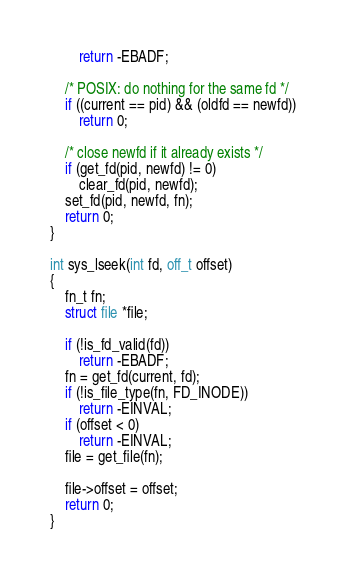Convert code to text. <code><loc_0><loc_0><loc_500><loc_500><_C_>        return -EBADF;

    /* POSIX: do nothing for the same fd */
    if ((current == pid) && (oldfd == newfd))
        return 0;

    /* close newfd if it already exists */
    if (get_fd(pid, newfd) != 0)
        clear_fd(pid, newfd);
    set_fd(pid, newfd, fn);
    return 0;
}

int sys_lseek(int fd, off_t offset)
{
    fn_t fn;
    struct file *file;

    if (!is_fd_valid(fd))
        return -EBADF;
    fn = get_fd(current, fd);
    if (!is_file_type(fn, FD_INODE))
        return -EINVAL;
    if (offset < 0)
        return -EINVAL;
    file = get_file(fn);

    file->offset = offset;
    return 0;
}
</code> 